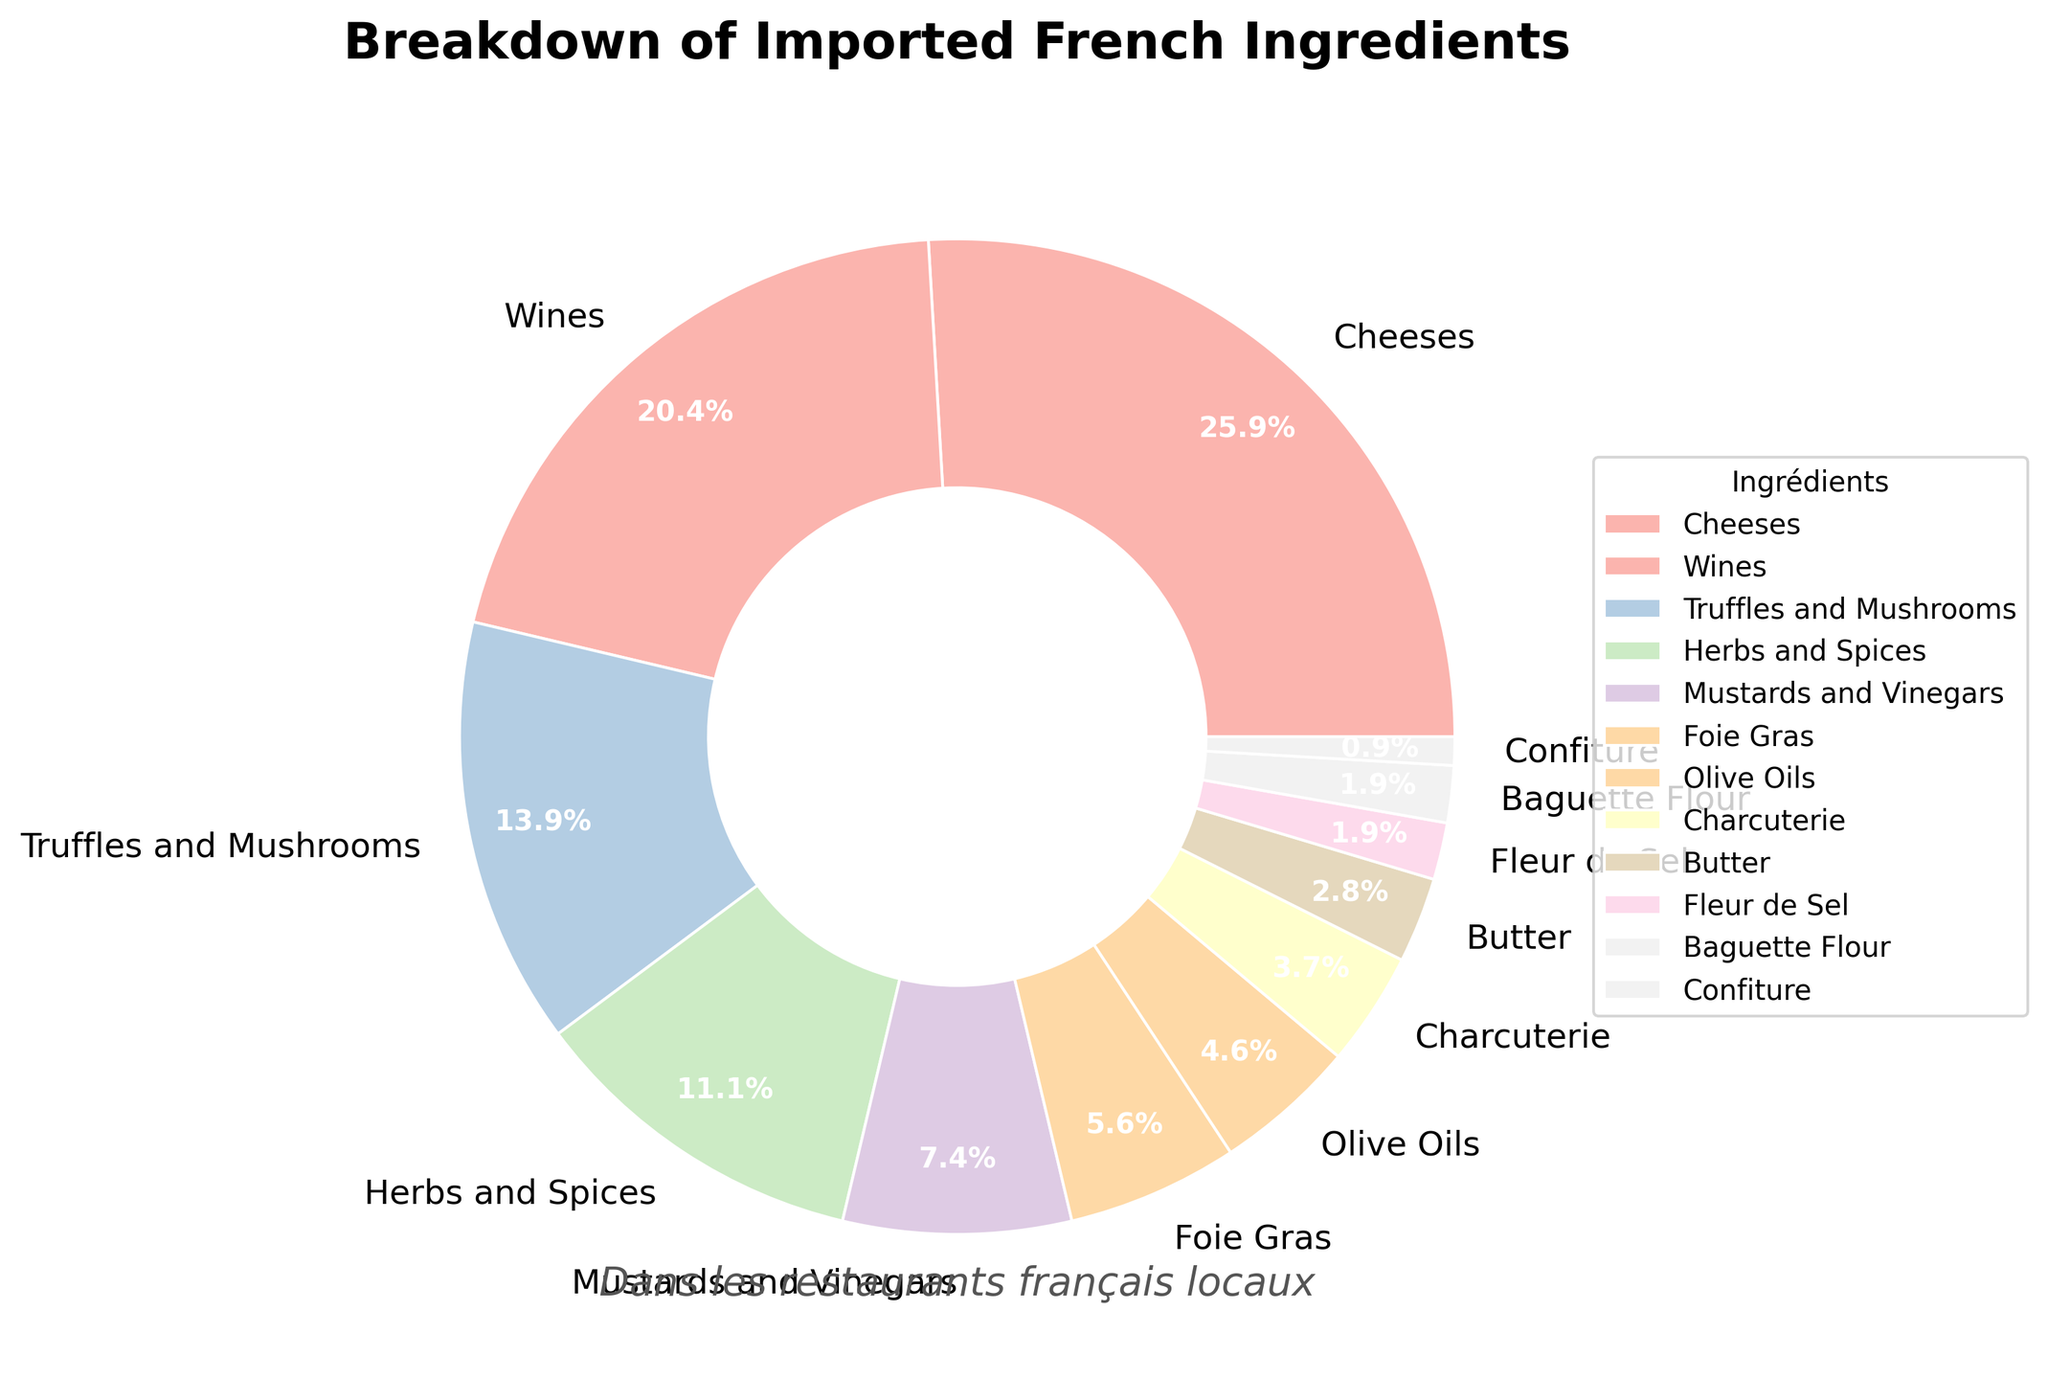What is the total percentage of Cheeses and Wines combined? The figure shows that Cheeses are 28% and Wines are 22%. Adding these together (28% + 22%) gives us the total percentage for Cheeses and Wines combined.
Answer: 50% Which category has the smallest percentage? The figure shows different percentage values for all categories. The category with the smallest percentage is Confiture, which has 1%.
Answer: Confiture How much greater is the percentage of Cheeses compared to Foie Gras? According to the figure, Cheeses are 28% and Foie Gras is 6%. Subtracting 6% from 28% gives us the difference. 28% - 6% = 22%.
Answer: 22% Are Mustards and Vinegars more or less than Herbs and Spices? By how much? The figure shows that Mustards and Vinegars are 8% while Herbs and Spices are 12%. Since 12% is greater than 8%, Herbs and Spices are more. The difference is 12% - 8% = 4%.
Answer: More by 4% What is the combined percentage for categories with less than 5%? The categories with less than 5% are Charcuterie (4%), Butter (3%), Fleur de Sel (2%), Baguette Flour (2%), and Confiture (1%). Adding these together gives us 4% + 3% + 2% + 2% + 1% = 12%.
Answer: 12% What are the colors used in the pie chart visually? The pie chart uses a variety of pastel colors as shown in the figure, including pastel shades like light pink, light purple, soft blue, light green, peach, etc.
Answer: Pastel shades Which category occupies the largest section in the pie chart, and what is its percentage? By visually inspecting the pie chart, the largest section belongs to Cheeses with a percentage of 28%.
Answer: Cheeses, 28% How do the percentages of Truffles and Mushrooms compare to Olive Oils? The figure indicates that Truffles and Mushrooms are 15% and Olive Oils are 5%. Since 15% is greater than 5%, Truffles and Mushrooms have a higher percentage than Olive Oils.
Answer: Truffles and Mushrooms 15% > Olive Oils 5% What's the difference in percentage between the category with the highest and the lowest percentage? The category with the highest percentage is Cheeses (28%) and the one with the lowest is Confiture (1%). The difference is 28% - 1% = 27%.
Answer: 27% Which category adds up to just below 10% when combined with Baguette Flour? Baguette Flour is 2%. To get just below 10% when combined, we need another category whose percentage adds up close yet below 8%. Foie Gras is 6%. 2% + 6% = 8%, which is just below 10%.
Answer: Foie Gras 